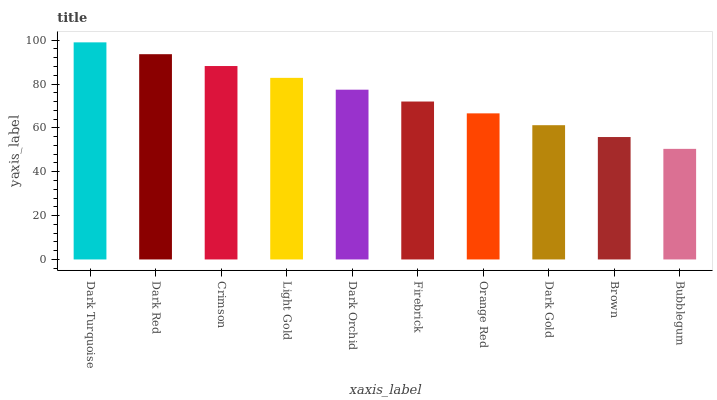Is Bubblegum the minimum?
Answer yes or no. Yes. Is Dark Turquoise the maximum?
Answer yes or no. Yes. Is Dark Red the minimum?
Answer yes or no. No. Is Dark Red the maximum?
Answer yes or no. No. Is Dark Turquoise greater than Dark Red?
Answer yes or no. Yes. Is Dark Red less than Dark Turquoise?
Answer yes or no. Yes. Is Dark Red greater than Dark Turquoise?
Answer yes or no. No. Is Dark Turquoise less than Dark Red?
Answer yes or no. No. Is Dark Orchid the high median?
Answer yes or no. Yes. Is Firebrick the low median?
Answer yes or no. Yes. Is Brown the high median?
Answer yes or no. No. Is Dark Gold the low median?
Answer yes or no. No. 